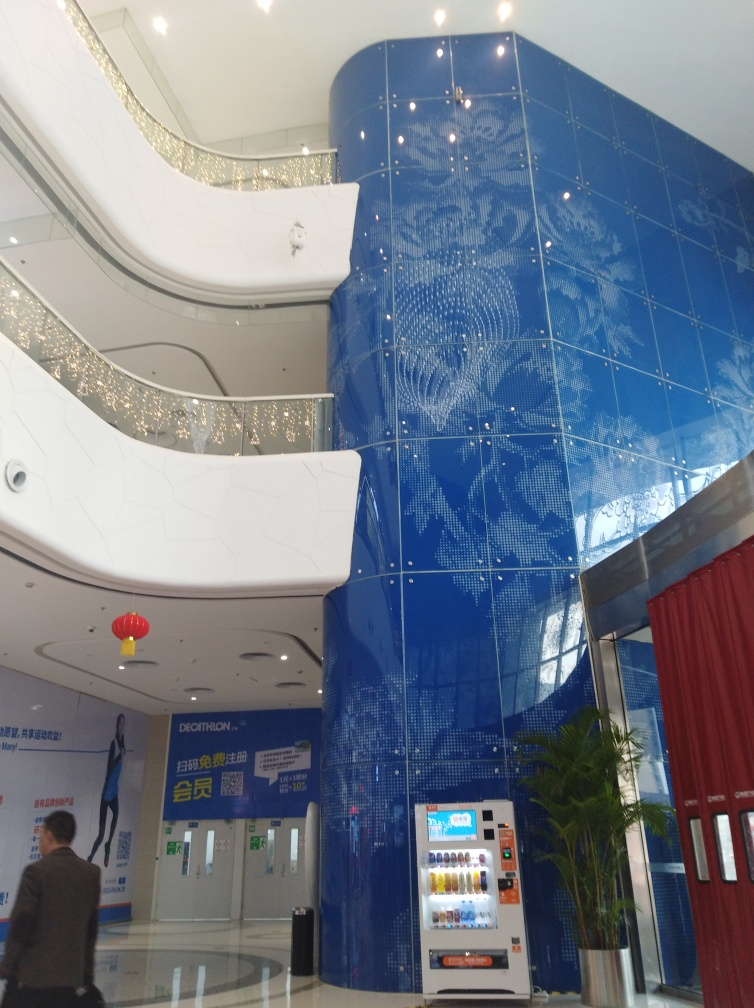What is the possible purpose of this space, based on what is visible in the image? From the image, it appears to be a public or commercial building. The presence of vending machines, advertisement banners, and a walkway suggests a space designed to cater to visitors, potentially a lobby or gathering area within a convention center, shopping mall, or a corporate building. Are there any details that give clues about the location or cultural context? The design elements, such as the red lantern hanging from the ceiling and the advertisements in the language on the banners, indicate a probable location in an East Asian context, possibly China. This cultural context may influence both the architectural and interior design choices observed in the image. 